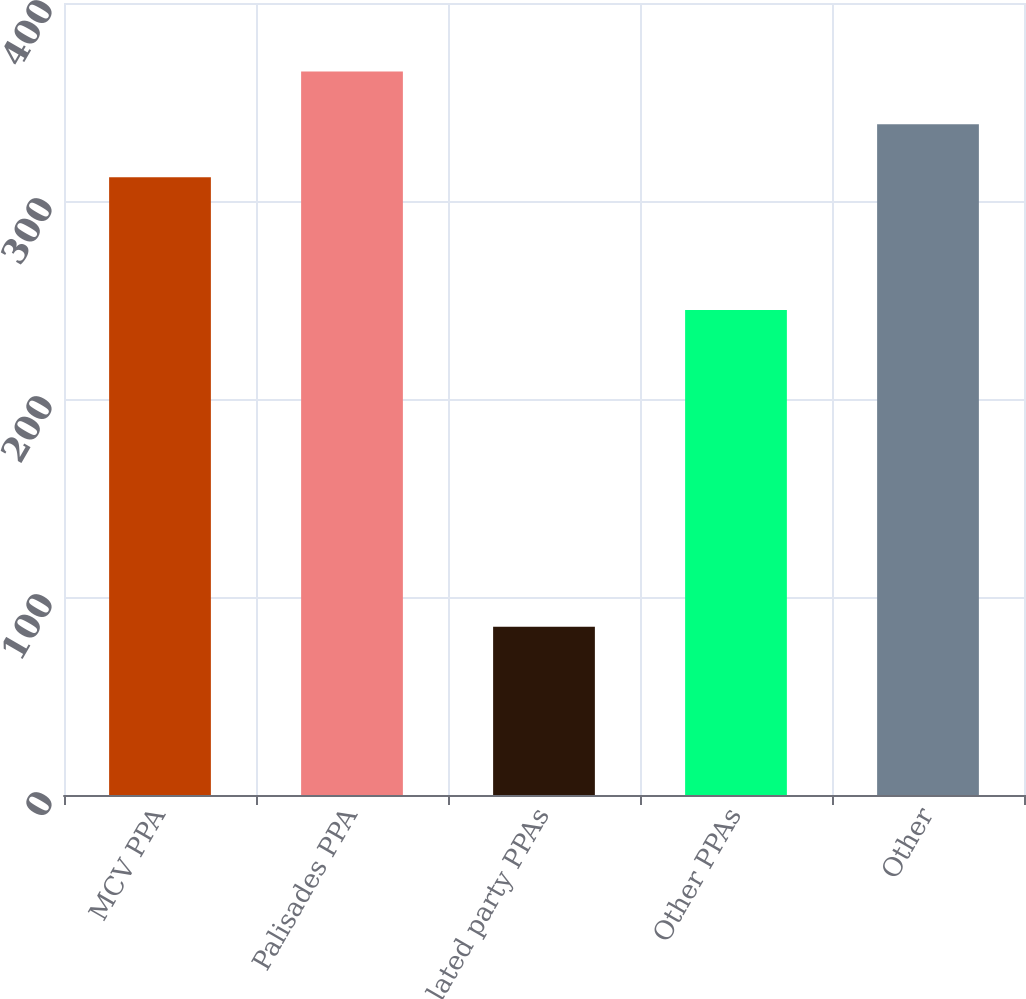Convert chart to OTSL. <chart><loc_0><loc_0><loc_500><loc_500><bar_chart><fcel>MCV PPA<fcel>Palisades PPA<fcel>Related party PPAs<fcel>Other PPAs<fcel>Other<nl><fcel>312<fcel>365.4<fcel>85<fcel>245<fcel>338.7<nl></chart> 